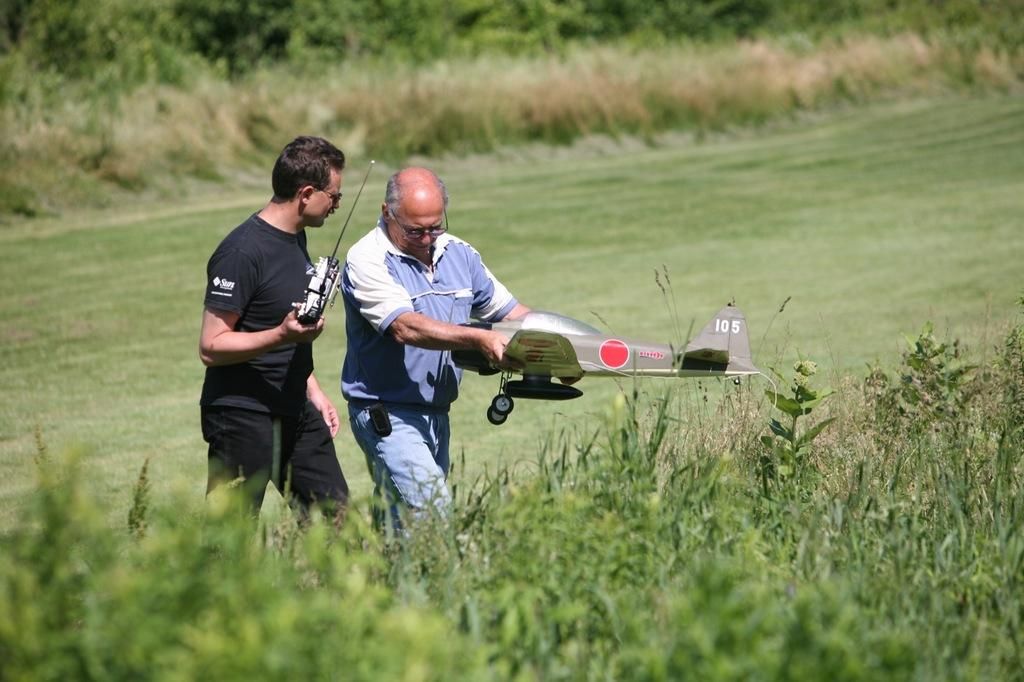How many people are in the image? There are two men in the image. What are the men holding in the image? The men are holding something. What type of terrain is visible at the bottom of the image? There is grass at the bottom of the image. What can be seen in the background of the image? There are trees in the background of the image. What type of insurance policy is being discussed by the men in the image? There is no indication in the image that the men are discussing any insurance policies. 